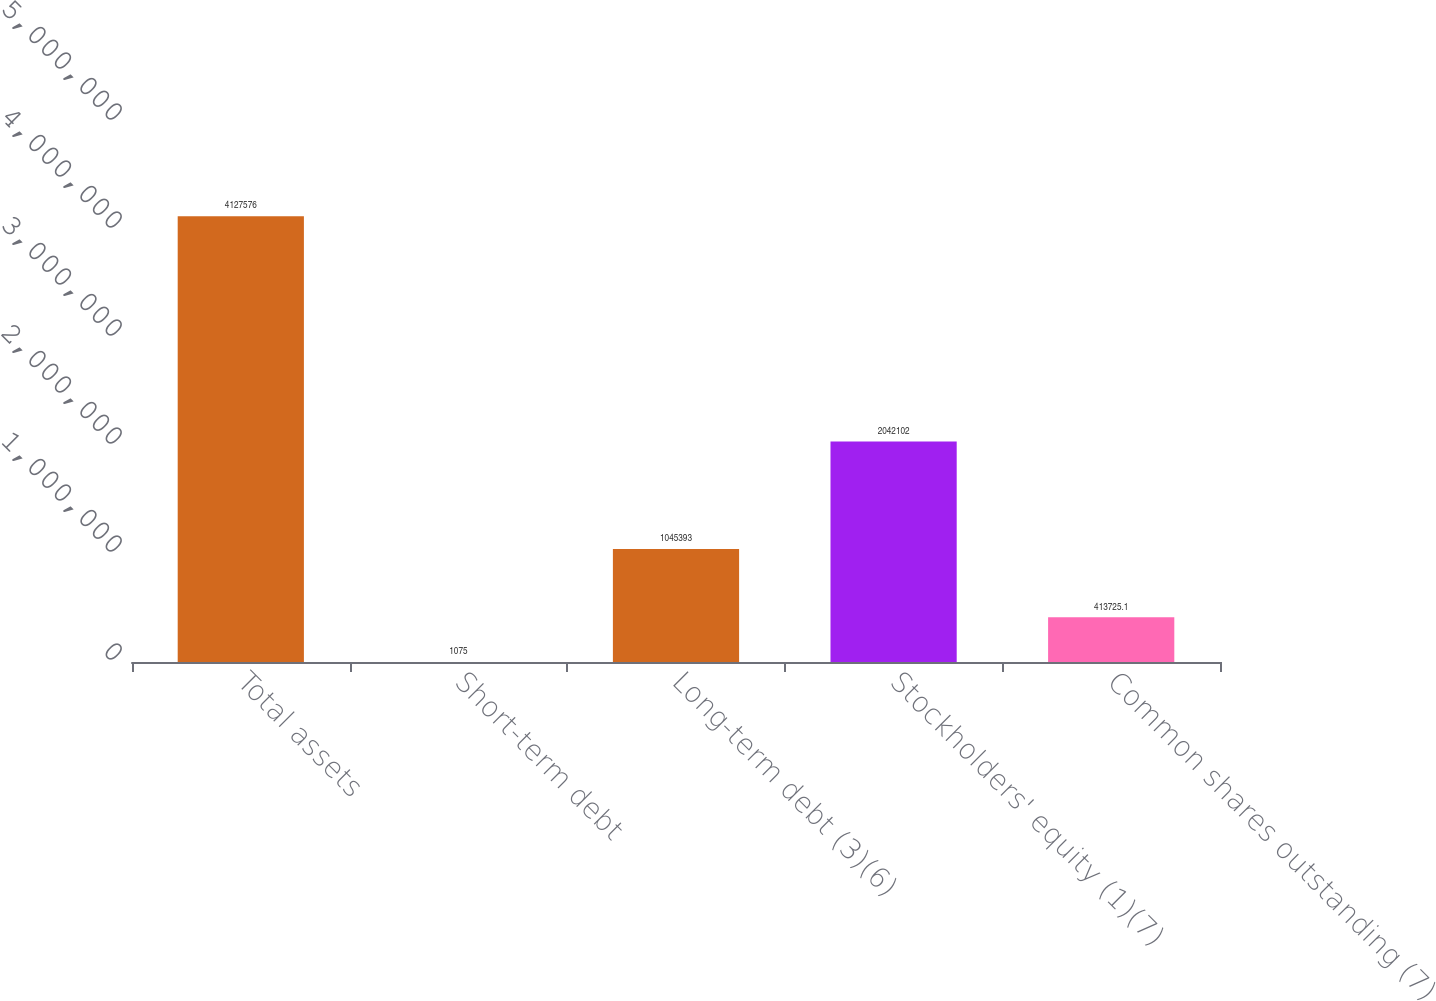Convert chart. <chart><loc_0><loc_0><loc_500><loc_500><bar_chart><fcel>Total assets<fcel>Short-term debt<fcel>Long-term debt (3)(6)<fcel>Stockholders' equity (1)(7)<fcel>Common shares outstanding (7)<nl><fcel>4.12758e+06<fcel>1075<fcel>1.04539e+06<fcel>2.0421e+06<fcel>413725<nl></chart> 